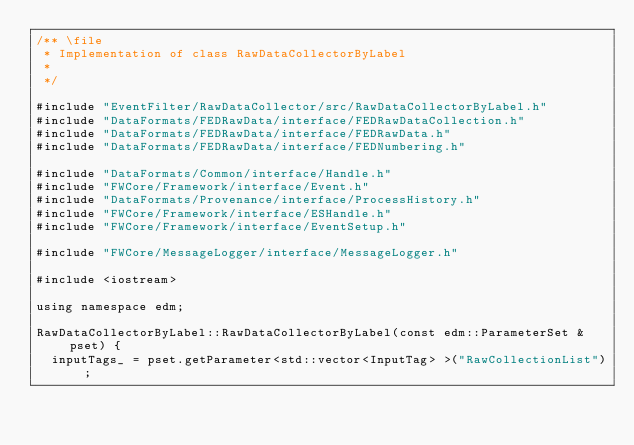Convert code to text. <code><loc_0><loc_0><loc_500><loc_500><_C++_>/** \file
 * Implementation of class RawDataCollectorByLabel
 *
 */

#include "EventFilter/RawDataCollector/src/RawDataCollectorByLabel.h"
#include "DataFormats/FEDRawData/interface/FEDRawDataCollection.h"
#include "DataFormats/FEDRawData/interface/FEDRawData.h"
#include "DataFormats/FEDRawData/interface/FEDNumbering.h"

#include "DataFormats/Common/interface/Handle.h"
#include "FWCore/Framework/interface/Event.h"
#include "DataFormats/Provenance/interface/ProcessHistory.h"
#include "FWCore/Framework/interface/ESHandle.h"
#include "FWCore/Framework/interface/EventSetup.h"

#include "FWCore/MessageLogger/interface/MessageLogger.h"

#include <iostream>

using namespace edm;

RawDataCollectorByLabel::RawDataCollectorByLabel(const edm::ParameterSet &pset) {
  inputTags_ = pset.getParameter<std::vector<InputTag> >("RawCollectionList");</code> 